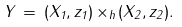Convert formula to latex. <formula><loc_0><loc_0><loc_500><loc_500>Y \, = \, ( X _ { 1 } , z _ { 1 } ) \, { \times } _ { h } \, ( X _ { 2 } , z _ { 2 } ) .</formula> 